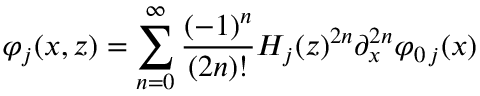<formula> <loc_0><loc_0><loc_500><loc_500>\varphi _ { j } ( x , z ) = \sum _ { n = 0 } ^ { \infty } \frac { ( - 1 ) ^ { n } } { ( 2 n ) ! } H _ { j } ( z ) ^ { 2 n } \partial _ { x } ^ { 2 n } \varphi _ { 0 \, j } ( x ) \,</formula> 